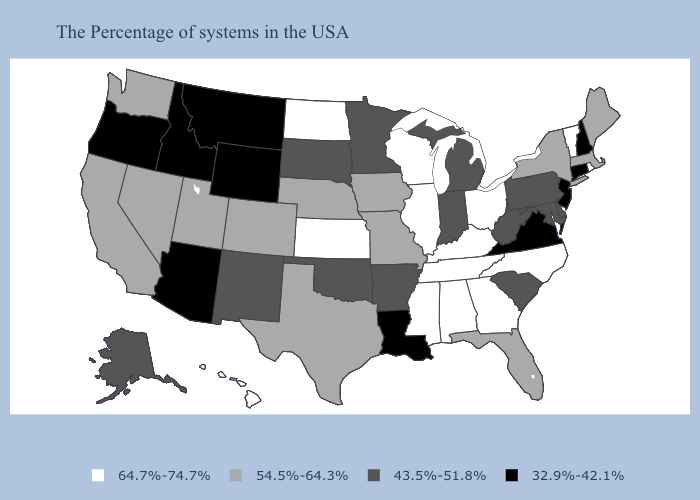What is the value of New York?
Be succinct. 54.5%-64.3%. Does Nebraska have a higher value than Tennessee?
Answer briefly. No. Name the states that have a value in the range 64.7%-74.7%?
Concise answer only. Rhode Island, Vermont, North Carolina, Ohio, Georgia, Kentucky, Alabama, Tennessee, Wisconsin, Illinois, Mississippi, Kansas, North Dakota, Hawaii. What is the value of Wisconsin?
Keep it brief. 64.7%-74.7%. Among the states that border Nevada , does California have the highest value?
Quick response, please. Yes. What is the value of Wisconsin?
Short answer required. 64.7%-74.7%. Does Vermont have the lowest value in the Northeast?
Quick response, please. No. What is the value of Hawaii?
Quick response, please. 64.7%-74.7%. Name the states that have a value in the range 54.5%-64.3%?
Be succinct. Maine, Massachusetts, New York, Florida, Missouri, Iowa, Nebraska, Texas, Colorado, Utah, Nevada, California, Washington. Name the states that have a value in the range 32.9%-42.1%?
Write a very short answer. New Hampshire, Connecticut, New Jersey, Virginia, Louisiana, Wyoming, Montana, Arizona, Idaho, Oregon. Which states have the lowest value in the South?
Write a very short answer. Virginia, Louisiana. Name the states that have a value in the range 43.5%-51.8%?
Answer briefly. Delaware, Maryland, Pennsylvania, South Carolina, West Virginia, Michigan, Indiana, Arkansas, Minnesota, Oklahoma, South Dakota, New Mexico, Alaska. Name the states that have a value in the range 43.5%-51.8%?
Be succinct. Delaware, Maryland, Pennsylvania, South Carolina, West Virginia, Michigan, Indiana, Arkansas, Minnesota, Oklahoma, South Dakota, New Mexico, Alaska. Name the states that have a value in the range 32.9%-42.1%?
Answer briefly. New Hampshire, Connecticut, New Jersey, Virginia, Louisiana, Wyoming, Montana, Arizona, Idaho, Oregon. Name the states that have a value in the range 32.9%-42.1%?
Quick response, please. New Hampshire, Connecticut, New Jersey, Virginia, Louisiana, Wyoming, Montana, Arizona, Idaho, Oregon. 